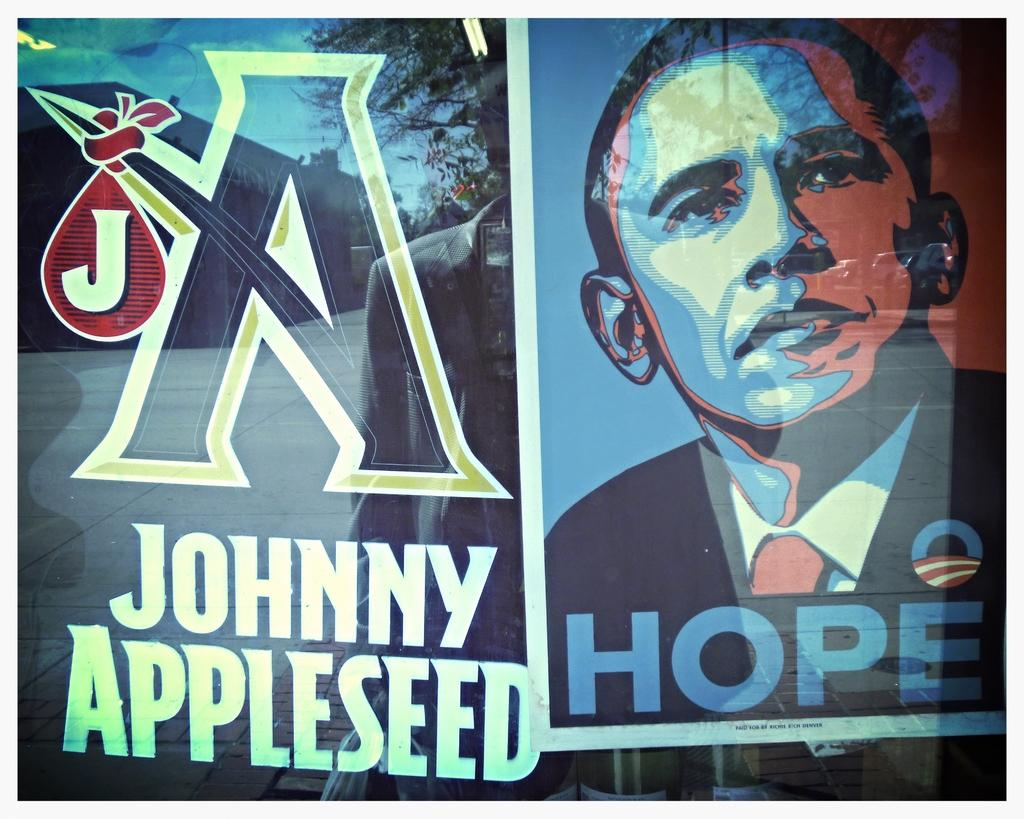<image>
Offer a succinct explanation of the picture presented. A poster of Barack Obama with the word hope underneath it. 